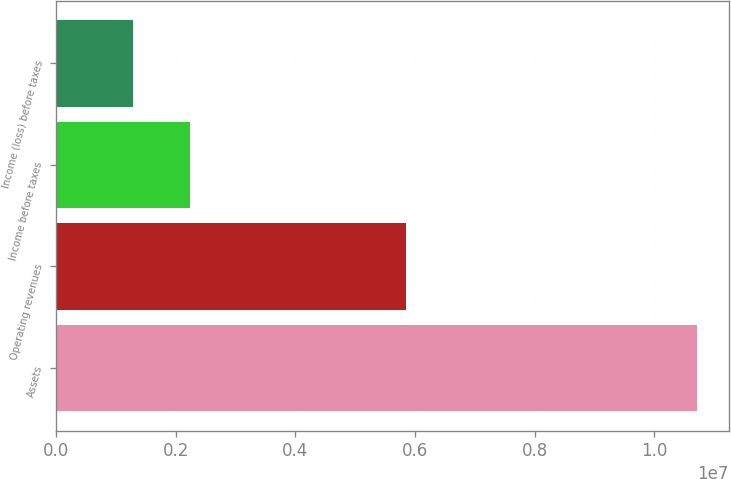Convert chart. <chart><loc_0><loc_0><loc_500><loc_500><bar_chart><fcel>Assets<fcel>Operating revenues<fcel>Income before taxes<fcel>Income (loss) before taxes<nl><fcel>1.07081e+07<fcel>5.853e+06<fcel>2.23055e+06<fcel>1.2886e+06<nl></chart> 